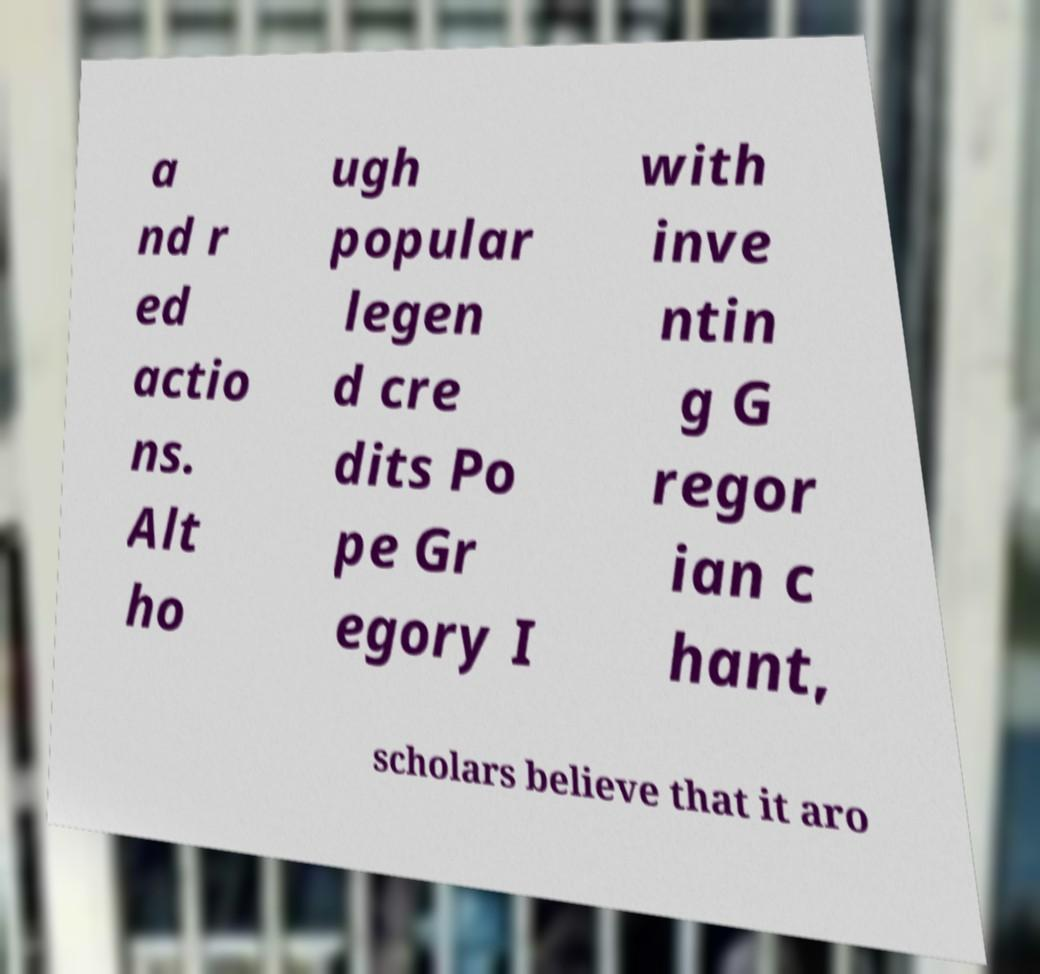I need the written content from this picture converted into text. Can you do that? a nd r ed actio ns. Alt ho ugh popular legen d cre dits Po pe Gr egory I with inve ntin g G regor ian c hant, scholars believe that it aro 